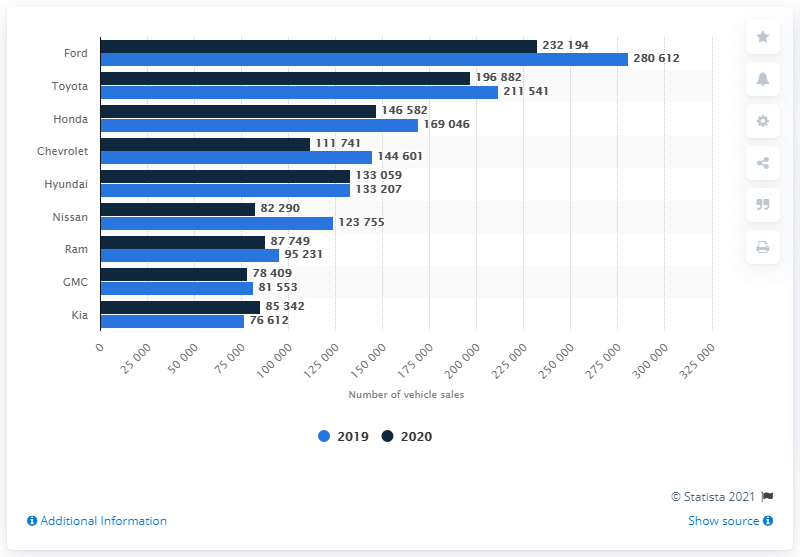Give some essential details in this illustration. Ford is the best-selling car brand in Canada, according to recent sales data. 